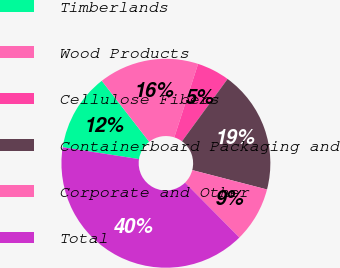<chart> <loc_0><loc_0><loc_500><loc_500><pie_chart><fcel>Timberlands<fcel>Wood Products<fcel>Cellulose Fibers<fcel>Containerboard Packaging and<fcel>Corporate and Other<fcel>Total<nl><fcel>12.03%<fcel>15.51%<fcel>5.07%<fcel>18.99%<fcel>8.55%<fcel>39.87%<nl></chart> 